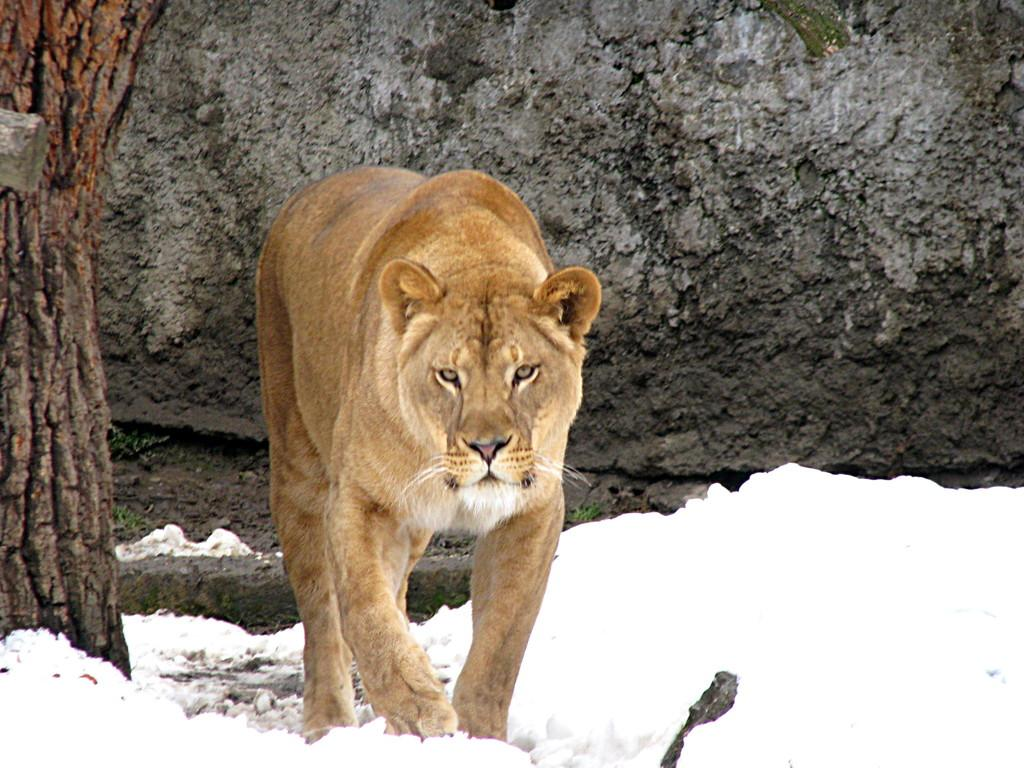What type of animal is in the image? There is a lioness in the image. What is the ground covered with in the image? There is snow on the ground in the image. What can be seen in the background of the image? There is a wall in the background of the image. What is located on the left side of the image? There is a tree trunk on the left side of the image. Where is the bucket located in the image? There is no bucket present in the image. What type of stone can be seen in the image? There is no stone visible in the image. 